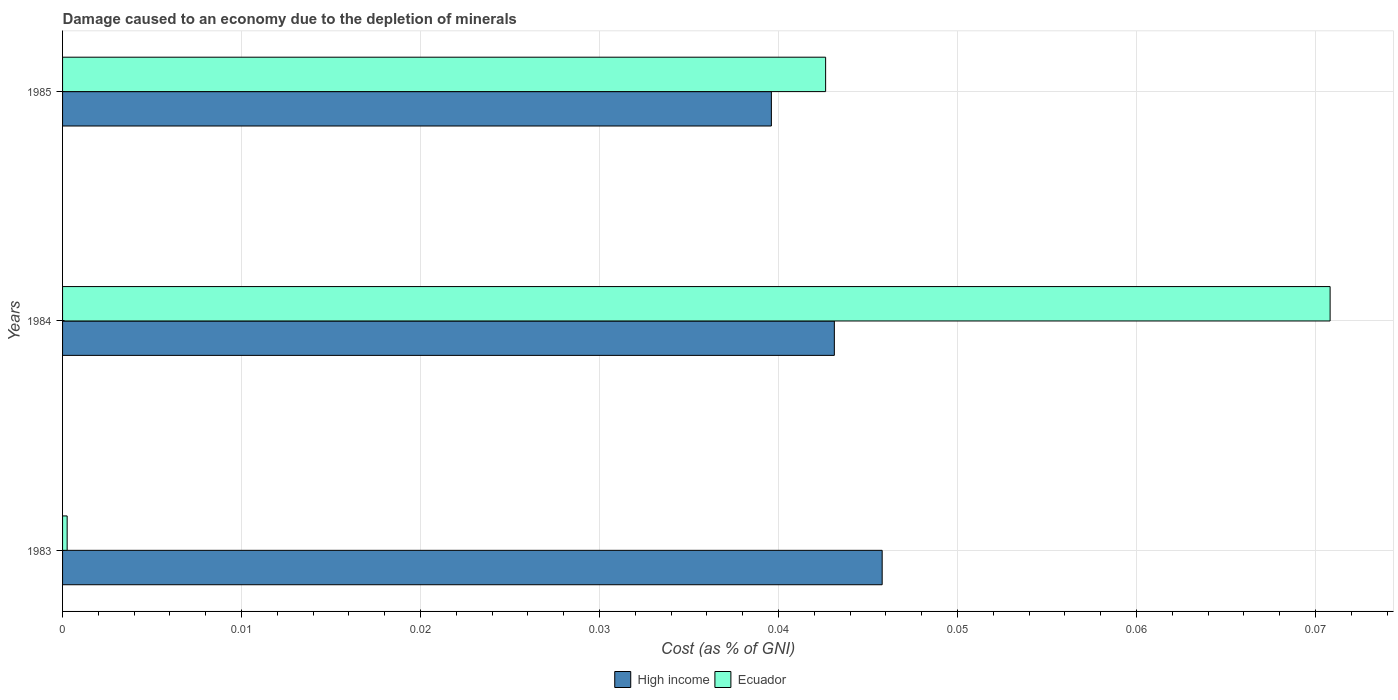How many different coloured bars are there?
Provide a succinct answer. 2. How many bars are there on the 3rd tick from the bottom?
Make the answer very short. 2. In how many cases, is the number of bars for a given year not equal to the number of legend labels?
Your response must be concise. 0. What is the cost of damage caused due to the depletion of minerals in Ecuador in 1983?
Make the answer very short. 0. Across all years, what is the maximum cost of damage caused due to the depletion of minerals in High income?
Your answer should be compact. 0.05. Across all years, what is the minimum cost of damage caused due to the depletion of minerals in Ecuador?
Your answer should be compact. 0. In which year was the cost of damage caused due to the depletion of minerals in High income maximum?
Your response must be concise. 1983. In which year was the cost of damage caused due to the depletion of minerals in Ecuador minimum?
Offer a terse response. 1983. What is the total cost of damage caused due to the depletion of minerals in Ecuador in the graph?
Your answer should be compact. 0.11. What is the difference between the cost of damage caused due to the depletion of minerals in High income in 1983 and that in 1984?
Give a very brief answer. 0. What is the difference between the cost of damage caused due to the depletion of minerals in Ecuador in 1983 and the cost of damage caused due to the depletion of minerals in High income in 1984?
Offer a terse response. -0.04. What is the average cost of damage caused due to the depletion of minerals in Ecuador per year?
Provide a short and direct response. 0.04. In the year 1985, what is the difference between the cost of damage caused due to the depletion of minerals in Ecuador and cost of damage caused due to the depletion of minerals in High income?
Give a very brief answer. 0. In how many years, is the cost of damage caused due to the depletion of minerals in Ecuador greater than 0.032 %?
Make the answer very short. 2. What is the ratio of the cost of damage caused due to the depletion of minerals in High income in 1984 to that in 1985?
Ensure brevity in your answer.  1.09. Is the cost of damage caused due to the depletion of minerals in Ecuador in 1983 less than that in 1984?
Ensure brevity in your answer.  Yes. What is the difference between the highest and the second highest cost of damage caused due to the depletion of minerals in Ecuador?
Provide a succinct answer. 0.03. What is the difference between the highest and the lowest cost of damage caused due to the depletion of minerals in High income?
Offer a very short reply. 0.01. In how many years, is the cost of damage caused due to the depletion of minerals in Ecuador greater than the average cost of damage caused due to the depletion of minerals in Ecuador taken over all years?
Provide a succinct answer. 2. Is the sum of the cost of damage caused due to the depletion of minerals in Ecuador in 1983 and 1984 greater than the maximum cost of damage caused due to the depletion of minerals in High income across all years?
Provide a short and direct response. Yes. What does the 2nd bar from the bottom in 1985 represents?
Offer a very short reply. Ecuador. How many bars are there?
Ensure brevity in your answer.  6. Are the values on the major ticks of X-axis written in scientific E-notation?
Offer a terse response. No. How many legend labels are there?
Your response must be concise. 2. What is the title of the graph?
Provide a succinct answer. Damage caused to an economy due to the depletion of minerals. What is the label or title of the X-axis?
Ensure brevity in your answer.  Cost (as % of GNI). What is the label or title of the Y-axis?
Offer a very short reply. Years. What is the Cost (as % of GNI) of High income in 1983?
Provide a short and direct response. 0.05. What is the Cost (as % of GNI) of Ecuador in 1983?
Provide a short and direct response. 0. What is the Cost (as % of GNI) in High income in 1984?
Provide a short and direct response. 0.04. What is the Cost (as % of GNI) of Ecuador in 1984?
Your response must be concise. 0.07. What is the Cost (as % of GNI) in High income in 1985?
Ensure brevity in your answer.  0.04. What is the Cost (as % of GNI) in Ecuador in 1985?
Your answer should be compact. 0.04. Across all years, what is the maximum Cost (as % of GNI) of High income?
Make the answer very short. 0.05. Across all years, what is the maximum Cost (as % of GNI) of Ecuador?
Offer a terse response. 0.07. Across all years, what is the minimum Cost (as % of GNI) in High income?
Offer a very short reply. 0.04. Across all years, what is the minimum Cost (as % of GNI) in Ecuador?
Offer a terse response. 0. What is the total Cost (as % of GNI) in High income in the graph?
Offer a very short reply. 0.13. What is the total Cost (as % of GNI) of Ecuador in the graph?
Your answer should be very brief. 0.11. What is the difference between the Cost (as % of GNI) of High income in 1983 and that in 1984?
Give a very brief answer. 0. What is the difference between the Cost (as % of GNI) in Ecuador in 1983 and that in 1984?
Ensure brevity in your answer.  -0.07. What is the difference between the Cost (as % of GNI) of High income in 1983 and that in 1985?
Your answer should be very brief. 0.01. What is the difference between the Cost (as % of GNI) in Ecuador in 1983 and that in 1985?
Your answer should be very brief. -0.04. What is the difference between the Cost (as % of GNI) in High income in 1984 and that in 1985?
Provide a short and direct response. 0. What is the difference between the Cost (as % of GNI) in Ecuador in 1984 and that in 1985?
Your answer should be very brief. 0.03. What is the difference between the Cost (as % of GNI) in High income in 1983 and the Cost (as % of GNI) in Ecuador in 1984?
Your response must be concise. -0.03. What is the difference between the Cost (as % of GNI) in High income in 1983 and the Cost (as % of GNI) in Ecuador in 1985?
Your answer should be compact. 0. What is the difference between the Cost (as % of GNI) of High income in 1984 and the Cost (as % of GNI) of Ecuador in 1985?
Your answer should be compact. 0. What is the average Cost (as % of GNI) of High income per year?
Your answer should be compact. 0.04. What is the average Cost (as % of GNI) in Ecuador per year?
Provide a succinct answer. 0.04. In the year 1983, what is the difference between the Cost (as % of GNI) in High income and Cost (as % of GNI) in Ecuador?
Your response must be concise. 0.05. In the year 1984, what is the difference between the Cost (as % of GNI) of High income and Cost (as % of GNI) of Ecuador?
Provide a succinct answer. -0.03. In the year 1985, what is the difference between the Cost (as % of GNI) in High income and Cost (as % of GNI) in Ecuador?
Make the answer very short. -0. What is the ratio of the Cost (as % of GNI) of High income in 1983 to that in 1984?
Make the answer very short. 1.06. What is the ratio of the Cost (as % of GNI) in Ecuador in 1983 to that in 1984?
Keep it short and to the point. 0. What is the ratio of the Cost (as % of GNI) of High income in 1983 to that in 1985?
Your answer should be compact. 1.16. What is the ratio of the Cost (as % of GNI) in Ecuador in 1983 to that in 1985?
Provide a succinct answer. 0.01. What is the ratio of the Cost (as % of GNI) of High income in 1984 to that in 1985?
Your response must be concise. 1.09. What is the ratio of the Cost (as % of GNI) in Ecuador in 1984 to that in 1985?
Offer a very short reply. 1.66. What is the difference between the highest and the second highest Cost (as % of GNI) in High income?
Offer a very short reply. 0. What is the difference between the highest and the second highest Cost (as % of GNI) of Ecuador?
Keep it short and to the point. 0.03. What is the difference between the highest and the lowest Cost (as % of GNI) of High income?
Keep it short and to the point. 0.01. What is the difference between the highest and the lowest Cost (as % of GNI) of Ecuador?
Your response must be concise. 0.07. 